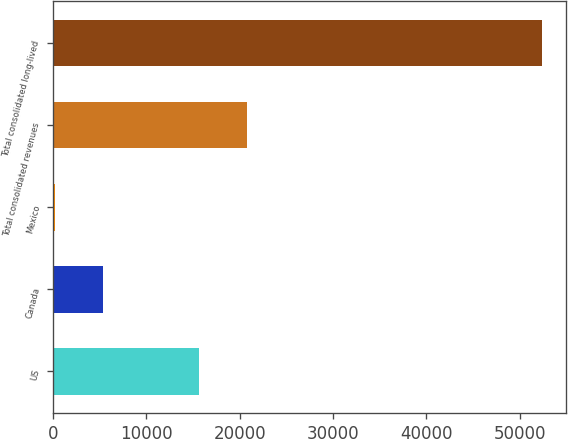<chart> <loc_0><loc_0><loc_500><loc_500><bar_chart><fcel>US<fcel>Canada<fcel>Mexico<fcel>Total consolidated revenues<fcel>Total consolidated long-lived<nl><fcel>15605<fcel>5399.7<fcel>184<fcel>20820.7<fcel>52341<nl></chart> 